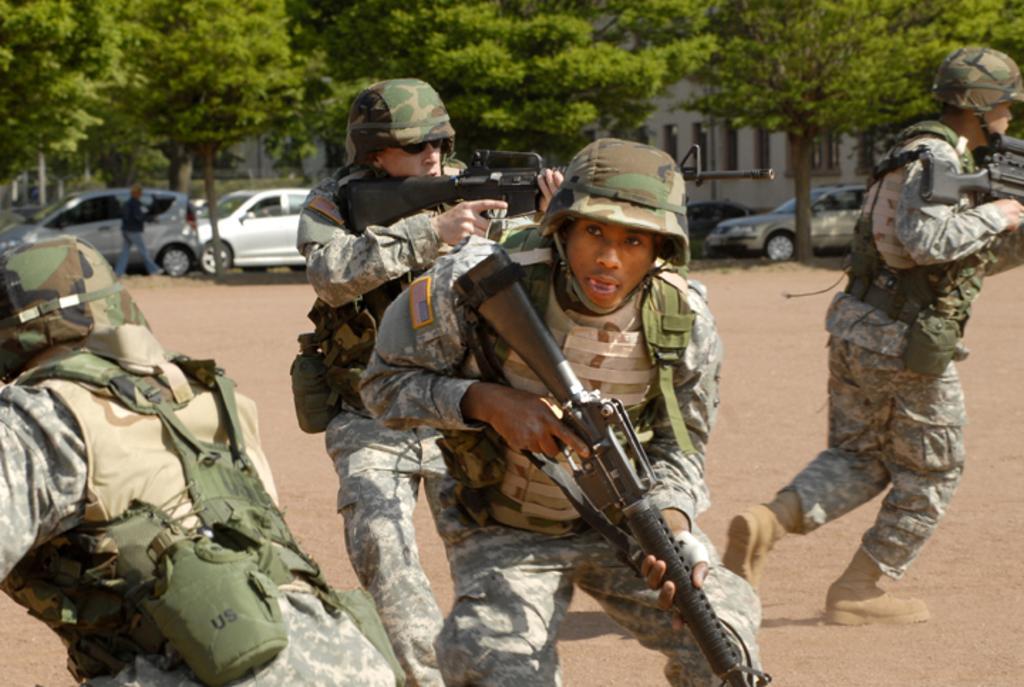Can you describe this image briefly? In this image I see 4 men who are wearing army uniform and I see that these 3 men are holding guns in their hands and I see that 4 of them are wearing helmets and I see the ground. In the background I see the cars and I see a person over here and I can also see the trees and a building over here. 